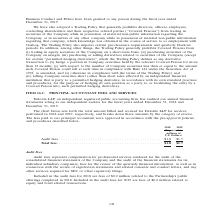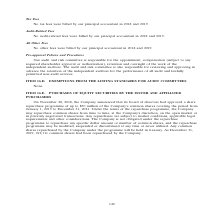From Gaslog's financial document, What are the components of fees recorded? The document contains multiple relevant values: Audit fees, Tax fees, Audit-related fees, All other fees. From the document: "2018 2019 (Expressed in millions of U.S. Dollars) Audit fees . $1.8 $1.7 Tax Fees Audit-Related Fees All Other Fees..." Also, What does audit fees represent? Compensation for professional services rendered for the audit of the consolidated financial statements of the Company and the audit of the financial statements for its individual subsidiary companies, fees for the review of the quarterly financial information, as well as in connection with the review of registration statements and related consents and comfort letters, and any other services required for SEC or other regulatory filings. The document states: "Audit fees represent compensation for professional services rendered for the audit of the consolidated financial statements of the Company and the aud..." Also, How much are the fees related to equity and bond related transactions in 2019? According to the financial document, $0.2 million. The relevant text states: "Included in the audit fees for 2018 are fees of $0.2 million related to the Partnership’s public offerings completed in 2018. Included in the audit fees for 2019 Included in the audit fees for 2018 ar..." Additionally, In which year was the audit fees lower? According to the financial document, 2019. The relevant text states: "2018 2019 (Expressed in millions of U.S. Dollars) Audit fees . $1.8 $1.7..." Also, can you calculate: What was the change in audit fees from 2018 to 2019? Based on the calculation: $1.7 - $1.8 , the result is -0.1 (in millions). This is based on the information: "ressed in millions of U.S. Dollars) Audit fees . $1.8 $1.7 d in millions of U.S. Dollars) Audit fees . $1.8 $1.7..." The key data points involved are: 1.7, 1.8. Also, can you calculate: What was the percentage change in total fees from 2018 to 2019? To answer this question, I need to perform calculations using the financial data. The calculation is: ($1.7 - $1.8)/$1.8 , which equals -5.56 (percentage). This is based on the information: "ressed in millions of U.S. Dollars) Audit fees . $1.8 $1.7 d in millions of U.S. Dollars) Audit fees . $1.8 $1.7..." The key data points involved are: 1.7, 1.8. 